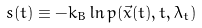Convert formula to latex. <formula><loc_0><loc_0><loc_500><loc_500>s ( t ) \equiv - k _ { B } \ln p ( \vec { x } ( t ) , t , \lambda _ { t } )</formula> 